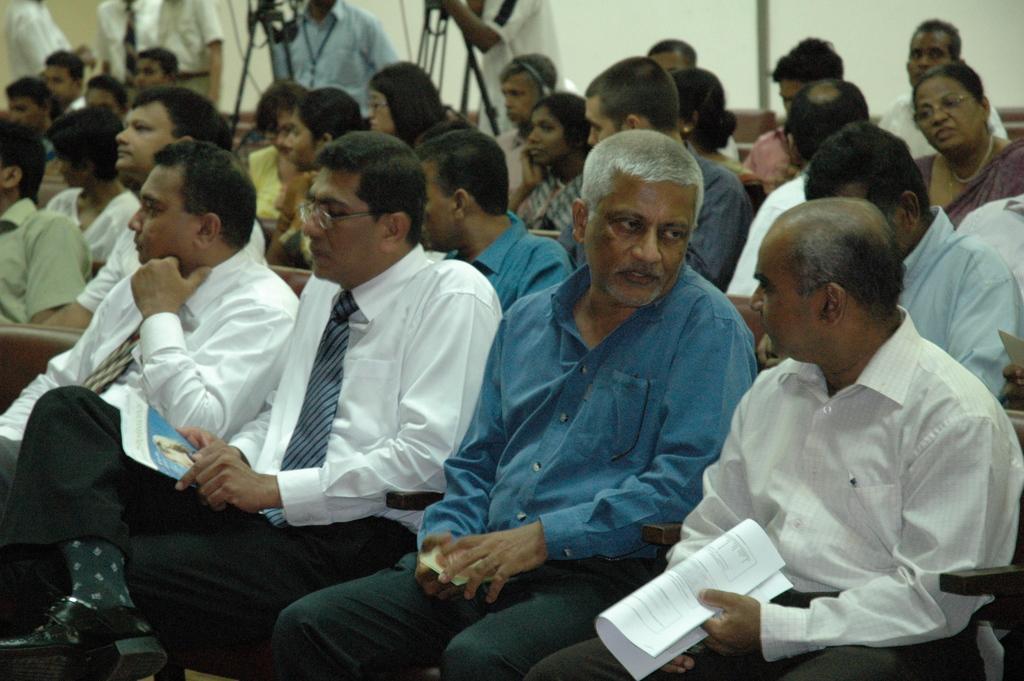Please provide a concise description of this image. In the middle of the image few people are sitting on chairs. Behind the few persons are standing and holding cameras. Top right side of the image there is wall. 